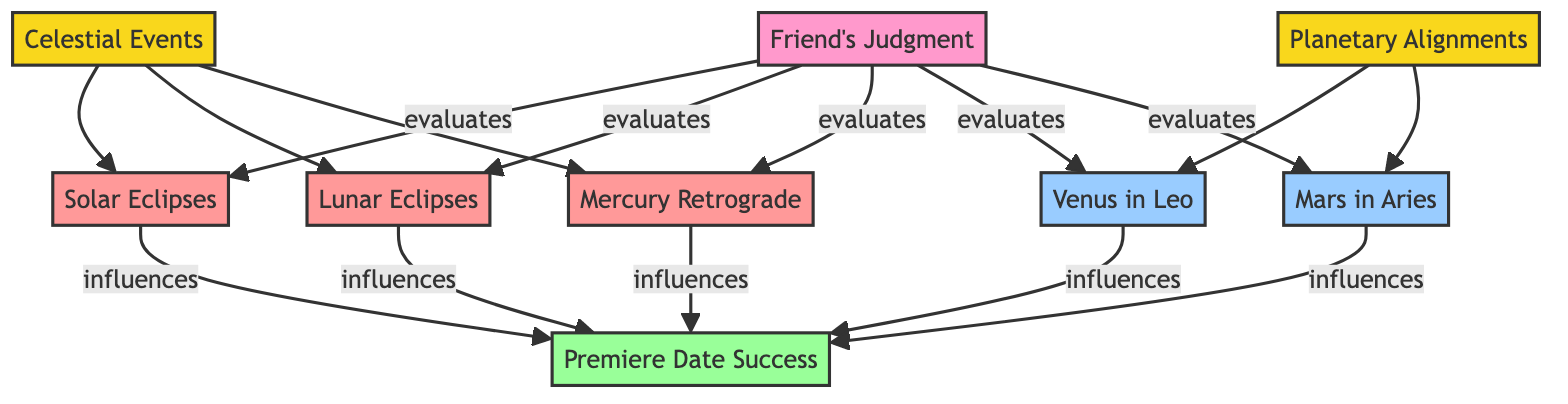What are the celestial events involved in the diagram? The diagram lists Solar Eclipses, Lunar Eclipses, and Mercury Retrograde as celestial events. These are connected directly to the "Celestial Events" node.
Answer: Solar Eclipses, Lunar Eclipses, Mercury Retrograde How many planetary alignments are shown? The diagram includes two planetary alignments: Venus in Leo and Mars in Aries. These alignments are connected directly to the "Planetary Alignments" node.
Answer: 2 Which celestial event influences premiere date success? The diagram indicates that Solar Eclipses, Lunar Eclipses, and Mercury Retrograde influence premiere date success, as they are connected to the "Premiere Date Success" node.
Answer: Solar Eclipses, Lunar Eclipses, Mercury Retrograde What role does the friend's judgment play in the diagram? The friend's judgment evaluates all celestial events and planetary alignments, as shown by the evaluations leading to the influences on premiere date success.
Answer: Evaluates Which influences come from Venus in Leo? Venus in Leo is a planetary alignment that influences premiere date success according to the diagram. There are no other direct influences stated related just to Venus in Leo.
Answer: Premiere Date Success How many outcomes are influenced in the diagram? The diagram indicates that there is one outcome, "Premiere Date Success," that is influenced by multiple factors including celestial events and planetary alignments.
Answer: 1 Are there any connections between lunar eclipses and premiere date success? Yes, according to the diagram, lunar eclipses influence premiere date success, as indicated by the direct connection between the "Lunar Eclipses" node and the "Premiere Date Success" node.
Answer: Yes What celestial events correlate with premiere date success? The celestial events that correlate with premiere date success in the diagram are Solar Eclipses, Lunar Eclipses, and Mercury Retrograde, as they influence the outcome directly.
Answer: Solar Eclipses, Lunar Eclipses, Mercury Retrograde 